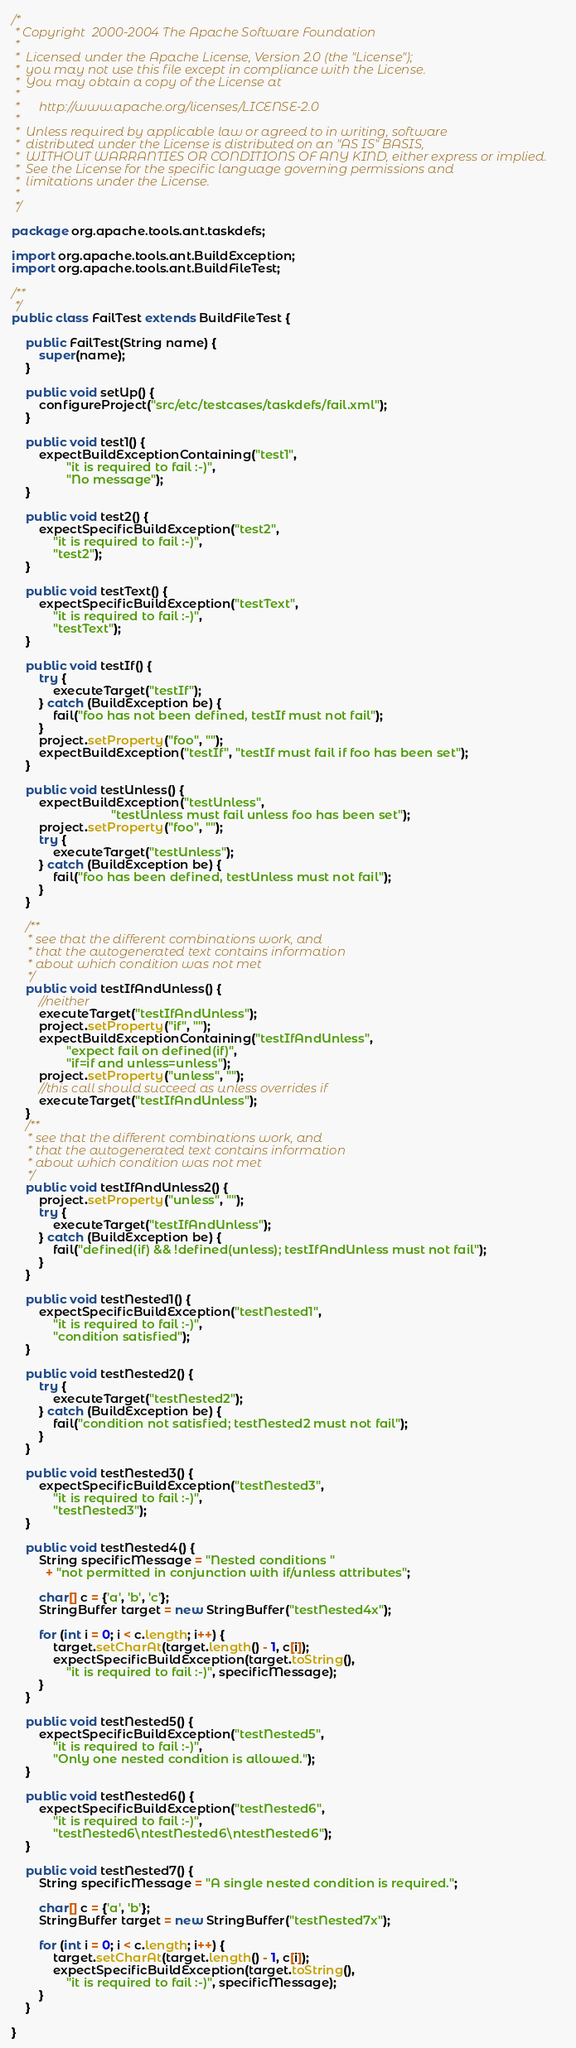Convert code to text. <code><loc_0><loc_0><loc_500><loc_500><_Java_>/*
 * Copyright  2000-2004 The Apache Software Foundation
 *
 *  Licensed under the Apache License, Version 2.0 (the "License");
 *  you may not use this file except in compliance with the License.
 *  You may obtain a copy of the License at
 *
 *      http://www.apache.org/licenses/LICENSE-2.0
 *
 *  Unless required by applicable law or agreed to in writing, software
 *  distributed under the License is distributed on an "AS IS" BASIS,
 *  WITHOUT WARRANTIES OR CONDITIONS OF ANY KIND, either express or implied.
 *  See the License for the specific language governing permissions and
 *  limitations under the License.
 *
 */

package org.apache.tools.ant.taskdefs;

import org.apache.tools.ant.BuildException;
import org.apache.tools.ant.BuildFileTest;

/**
 */
public class FailTest extends BuildFileTest {

    public FailTest(String name) {
        super(name);
    }

    public void setUp() {
        configureProject("src/etc/testcases/taskdefs/fail.xml");
    }

    public void test1() {
        expectBuildExceptionContaining("test1",
                "it is required to fail :-)",
                "No message");
    }

    public void test2() {
        expectSpecificBuildException("test2",
            "it is required to fail :-)",
            "test2");
    }

    public void testText() {
        expectSpecificBuildException("testText",
            "it is required to fail :-)",
            "testText");
    }

    public void testIf() {
        try {
            executeTarget("testIf");
        } catch (BuildException be) {
            fail("foo has not been defined, testIf must not fail");
        }
        project.setProperty("foo", "");
        expectBuildException("testIf", "testIf must fail if foo has been set");
    }

    public void testUnless() {
        expectBuildException("testUnless",
                             "testUnless must fail unless foo has been set");
        project.setProperty("foo", "");
        try {
            executeTarget("testUnless");
        } catch (BuildException be) {
            fail("foo has been defined, testUnless must not fail");
        }
    }

    /**
     * see that the different combinations work, and
     * that the autogenerated text contains information
     * about which condition was not met
     */
    public void testIfAndUnless() {
        //neither
        executeTarget("testIfAndUnless");
        project.setProperty("if", "");
        expectBuildExceptionContaining("testIfAndUnless",
                "expect fail on defined(if)",
                "if=if and unless=unless");
        project.setProperty("unless", "");
        //this call should succeed as unless overrides if
        executeTarget("testIfAndUnless");
    }
    /**
     * see that the different combinations work, and
     * that the autogenerated text contains information
     * about which condition was not met
     */
    public void testIfAndUnless2() {
        project.setProperty("unless", "");
        try {
            executeTarget("testIfAndUnless");
        } catch (BuildException be) {
            fail("defined(if) && !defined(unless); testIfAndUnless must not fail");
        }
    }

    public void testNested1() {
        expectSpecificBuildException("testNested1",
            "it is required to fail :-)",
            "condition satisfied");
    }

    public void testNested2() {
        try {
            executeTarget("testNested2");
        } catch (BuildException be) {
            fail("condition not satisfied; testNested2 must not fail");
        }
    }

    public void testNested3() {
        expectSpecificBuildException("testNested3",
            "it is required to fail :-)",
            "testNested3");
    }

    public void testNested4() {
        String specificMessage = "Nested conditions "
          + "not permitted in conjunction with if/unless attributes";

        char[] c = {'a', 'b', 'c'};
        StringBuffer target = new StringBuffer("testNested4x");

        for (int i = 0; i < c.length; i++) {
            target.setCharAt(target.length() - 1, c[i]);
            expectSpecificBuildException(target.toString(),
                "it is required to fail :-)", specificMessage);
        }
    }

    public void testNested5() {
        expectSpecificBuildException("testNested5",
            "it is required to fail :-)",
            "Only one nested condition is allowed.");
    }

    public void testNested6() {
        expectSpecificBuildException("testNested6",
            "it is required to fail :-)",
            "testNested6\ntestNested6\ntestNested6");
    }

    public void testNested7() {
        String specificMessage = "A single nested condition is required.";

        char[] c = {'a', 'b'};
        StringBuffer target = new StringBuffer("testNested7x");

        for (int i = 0; i < c.length; i++) {
            target.setCharAt(target.length() - 1, c[i]);
            expectSpecificBuildException(target.toString(),
                "it is required to fail :-)", specificMessage);
        }
    }

}
</code> 